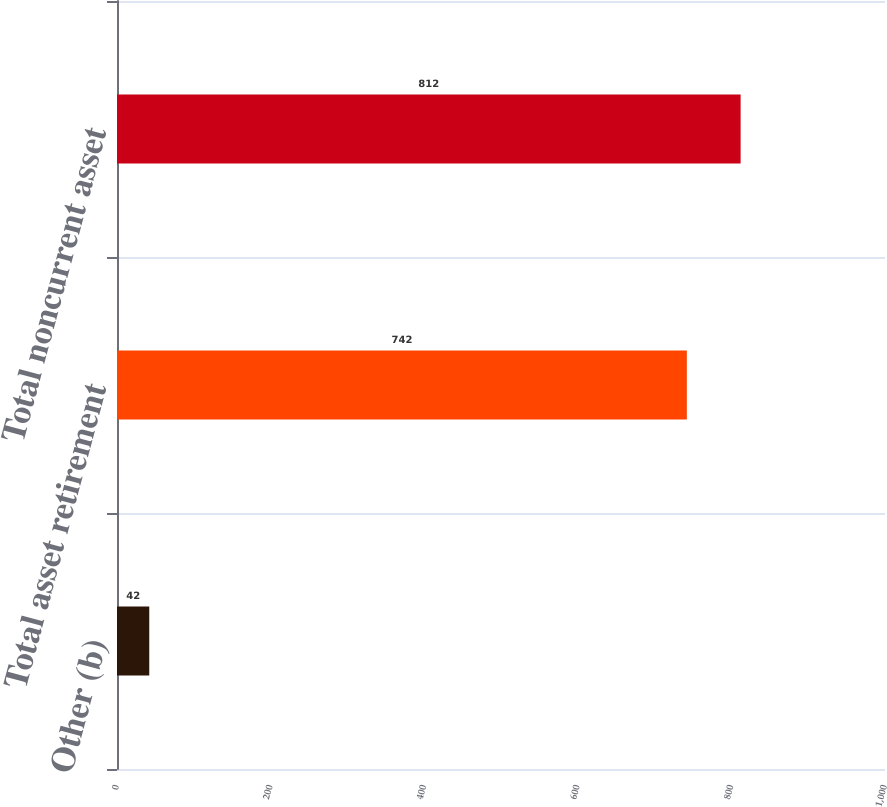Convert chart to OTSL. <chart><loc_0><loc_0><loc_500><loc_500><bar_chart><fcel>Other (b)<fcel>Total asset retirement<fcel>Total noncurrent asset<nl><fcel>42<fcel>742<fcel>812<nl></chart> 